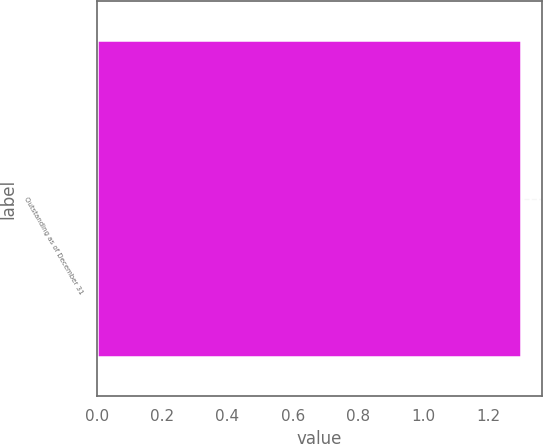Convert chart to OTSL. <chart><loc_0><loc_0><loc_500><loc_500><bar_chart><fcel>Outstanding as of December 31<nl><fcel>1.3<nl></chart> 